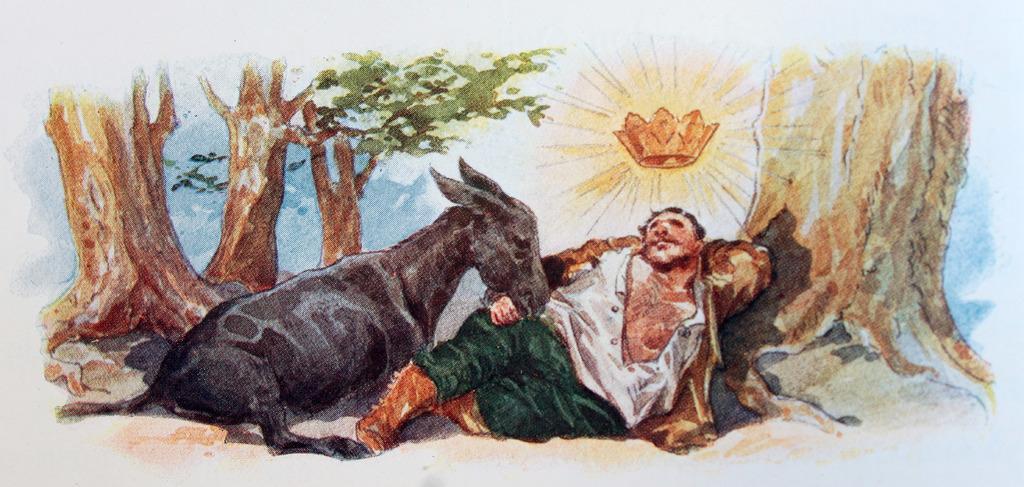Can you describe this image briefly? In this image I can see the paint of person, animal, sun and trees. The person is lying to the side of the tree and he wearing the white and green color dress. The animal is in black color. In the back I can see sun and the sky. 